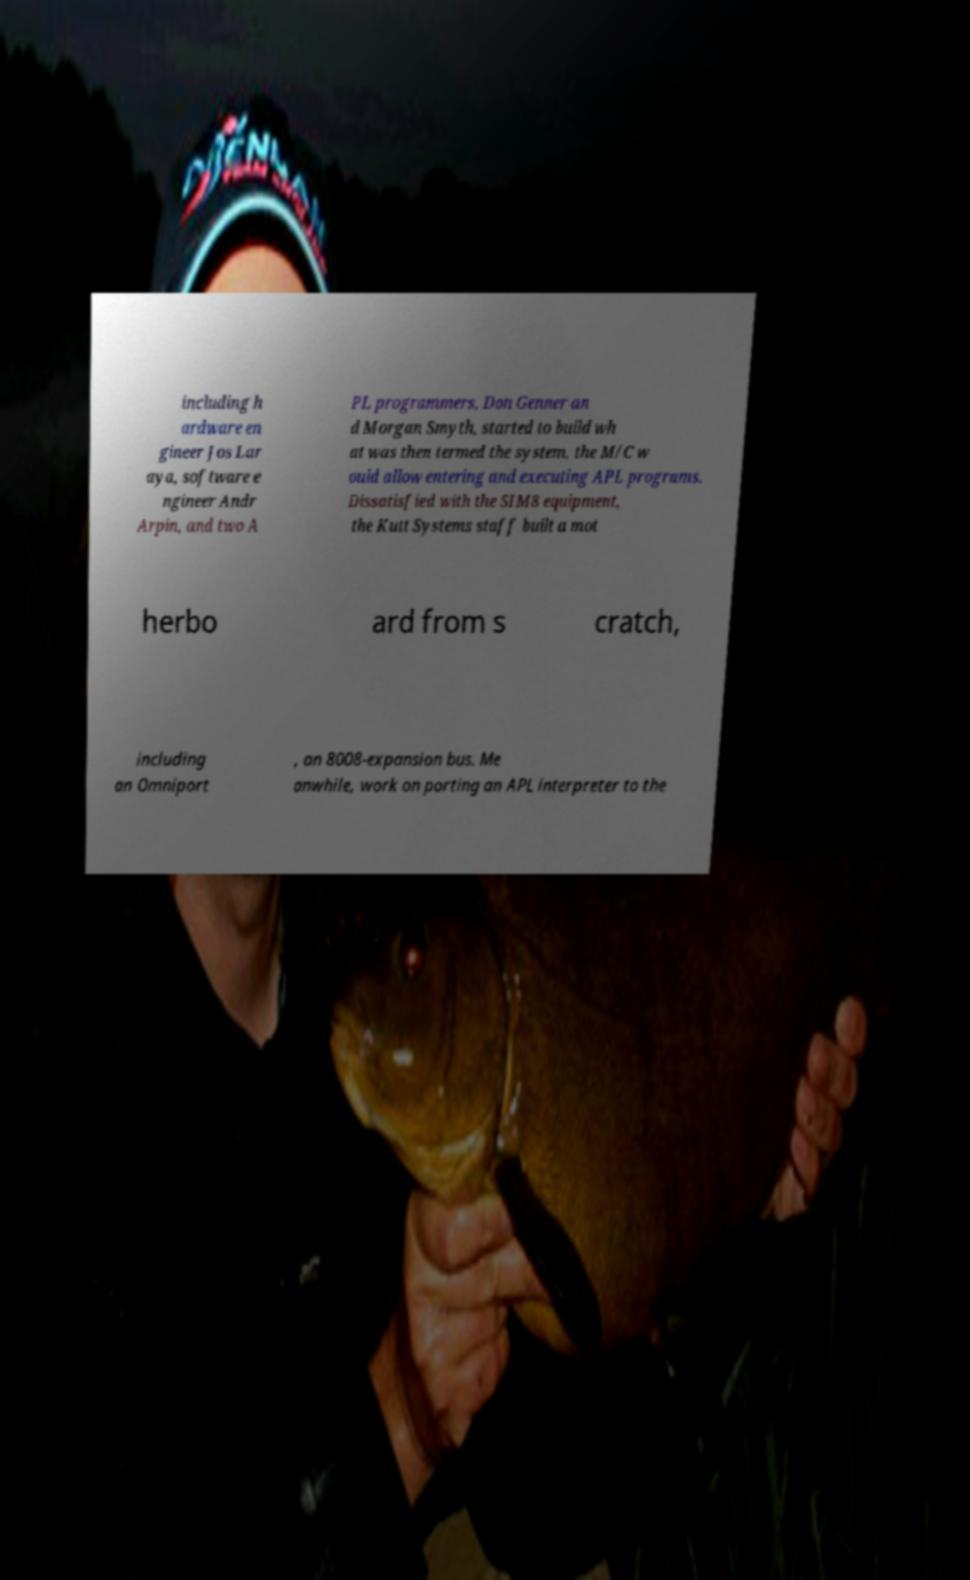For documentation purposes, I need the text within this image transcribed. Could you provide that? including h ardware en gineer Jos Lar aya, software e ngineer Andr Arpin, and two A PL programmers, Don Genner an d Morgan Smyth, started to build wh at was then termed the system, the M/C w ould allow entering and executing APL programs. Dissatisfied with the SIM8 equipment, the Kutt Systems staff built a mot herbo ard from s cratch, including an Omniport , an 8008-expansion bus. Me anwhile, work on porting an APL interpreter to the 